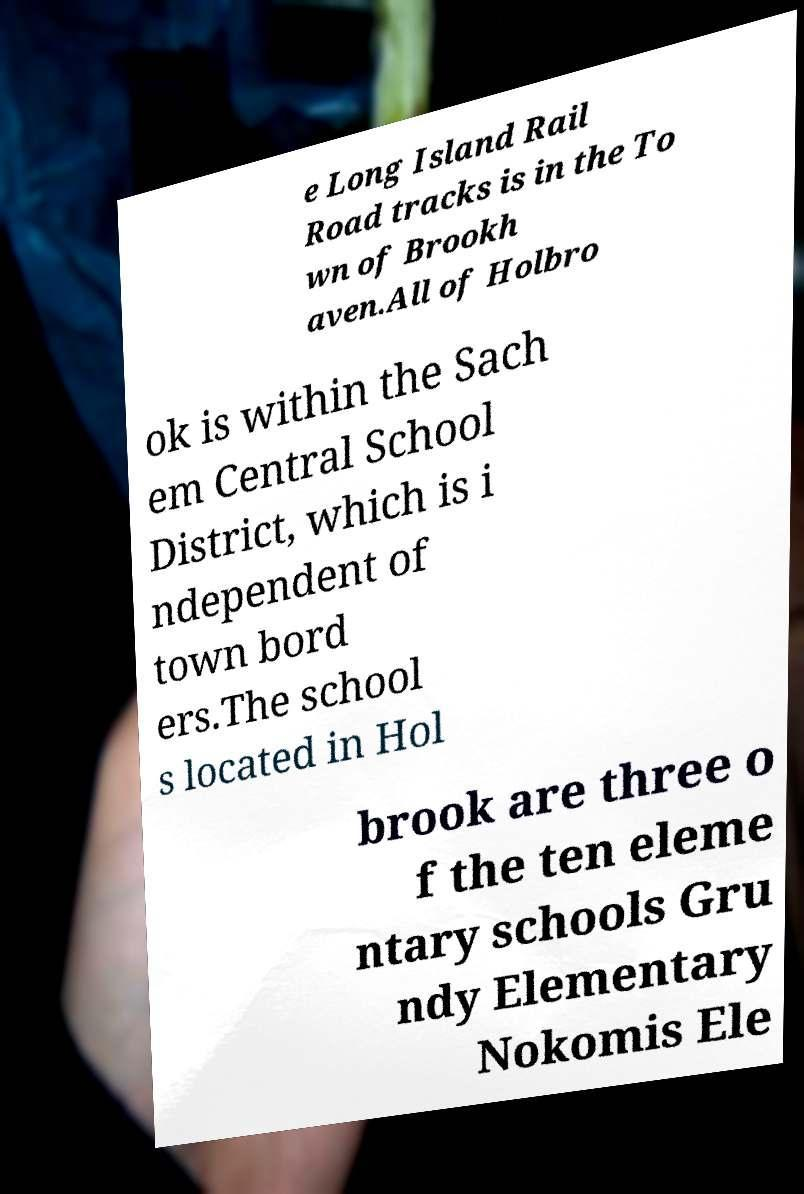For documentation purposes, I need the text within this image transcribed. Could you provide that? e Long Island Rail Road tracks is in the To wn of Brookh aven.All of Holbro ok is within the Sach em Central School District, which is i ndependent of town bord ers.The school s located in Hol brook are three o f the ten eleme ntary schools Gru ndy Elementary Nokomis Ele 